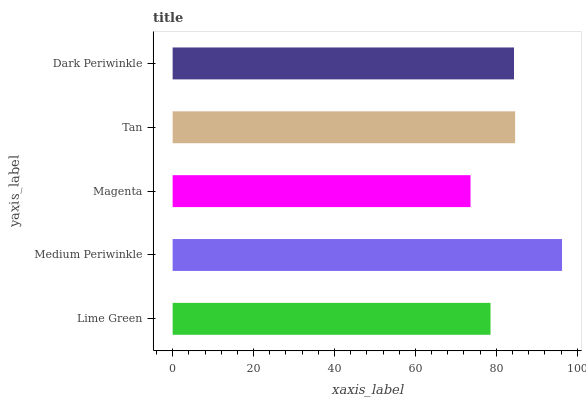Is Magenta the minimum?
Answer yes or no. Yes. Is Medium Periwinkle the maximum?
Answer yes or no. Yes. Is Medium Periwinkle the minimum?
Answer yes or no. No. Is Magenta the maximum?
Answer yes or no. No. Is Medium Periwinkle greater than Magenta?
Answer yes or no. Yes. Is Magenta less than Medium Periwinkle?
Answer yes or no. Yes. Is Magenta greater than Medium Periwinkle?
Answer yes or no. No. Is Medium Periwinkle less than Magenta?
Answer yes or no. No. Is Dark Periwinkle the high median?
Answer yes or no. Yes. Is Dark Periwinkle the low median?
Answer yes or no. Yes. Is Medium Periwinkle the high median?
Answer yes or no. No. Is Lime Green the low median?
Answer yes or no. No. 